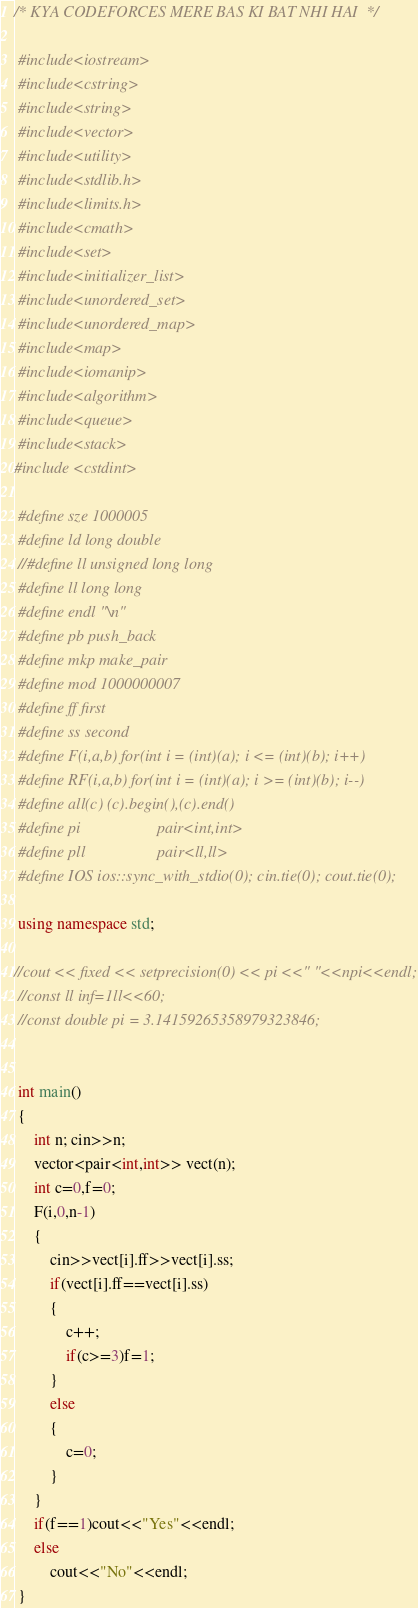Convert code to text. <code><loc_0><loc_0><loc_500><loc_500><_C++_>/* KYA CODEFORCES MERE BAS KI BAT NHI HAI  */
 
 #include<iostream>
 #include<cstring>
 #include<string>
 #include<vector>
 #include<utility>
 #include<stdlib.h>
 #include<limits.h>
 #include<cmath>
 #include<set>
 #include<initializer_list>
 #include<unordered_set>
 #include<unordered_map>
 #include<map>
 #include<iomanip>
 #include<algorithm>
 #include<queue>
 #include<stack>
#include <cstdint>
  
 #define sze 1000005
 #define ld long double
 //#define ll unsigned long long
 #define ll long long
 #define endl "\n"
 #define pb push_back
 #define mkp make_pair
 #define mod 1000000007
 #define ff first
 #define ss second
 #define F(i,a,b) for(int i = (int)(a); i <= (int)(b); i++)
 #define RF(i,a,b) for(int i = (int)(a); i >= (int)(b); i--)
 #define all(c) (c).begin(),(c).end()
 #define pi                   pair<int,int>
 #define pll                  pair<ll,ll>
 #define IOS ios::sync_with_stdio(0); cin.tie(0); cout.tie(0);
  
 using namespace std;
 
//cout << fixed << setprecision(0) << pi <<" "<<npi<<endl;
 //const ll inf=1ll<<60;
 //const double pi = 3.14159265358979323846;


 int main()
 {
     int n; cin>>n;
     vector<pair<int,int>> vect(n);
     int c=0,f=0;
     F(i,0,n-1)
     {
         cin>>vect[i].ff>>vect[i].ss;
         if(vect[i].ff==vect[i].ss)
         {
             c++;
             if(c>=3)f=1;
         }
         else
         {
             c=0;
         }
     }
     if(f==1)cout<<"Yes"<<endl;
     else
         cout<<"No"<<endl;
 }
</code> 